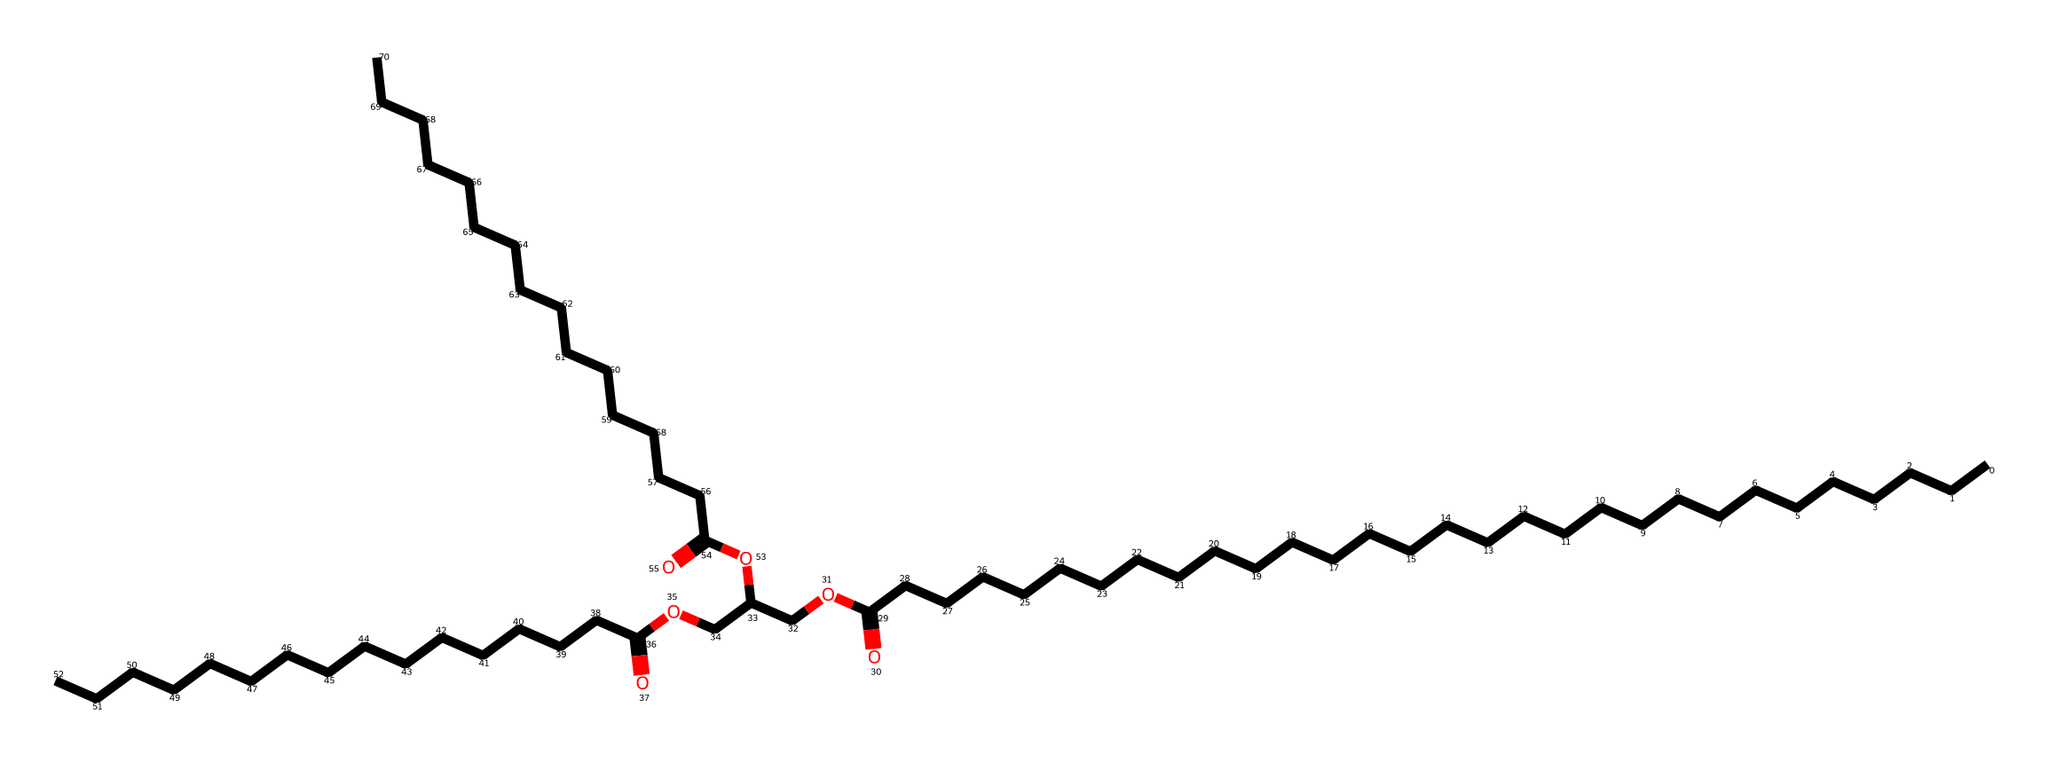what is the main functional group present in beeswax? The structural formula indicates the presence of ester functional groups, as seen from the carbonyl groups linked to oxygen atoms (the carbonyls are part of the ester functional groups).
Answer: ester how many carbons are in the longest carbon chain of beeswax? By examining the SMILES representation, the longest continuous carbon chain can be traced from the left, revealing that there are 30 carbon atoms in total.
Answer: 30 what type of lubricant is beeswax considered? Beeswax is identified as a natural lubricant due to its origin and composed of fatty acids and esters, which are commonly used for lubrication purposes in various applications.
Answer: natural lubricant how many ester linkages are present in the beeswax molecule? The structural formula reveals three separate ester linkages linking different carbon chains through the carbonyl and oxygen atoms.
Answer: 3 what is the saturation state of the fatty acids in beeswax? The long carbon chains have single bonds only, indicating that the fatty acids in beeswax are saturated, meaning they contain no double bonds.
Answer: saturated which characteristic of beeswax makes it suitable for use in vellum manuscript making? The low friction and protective qualities of beeswax, attributed to its waxy consistency and lubricating properties, make it ideal for reducing wear on vellum during writing.
Answer: low friction 